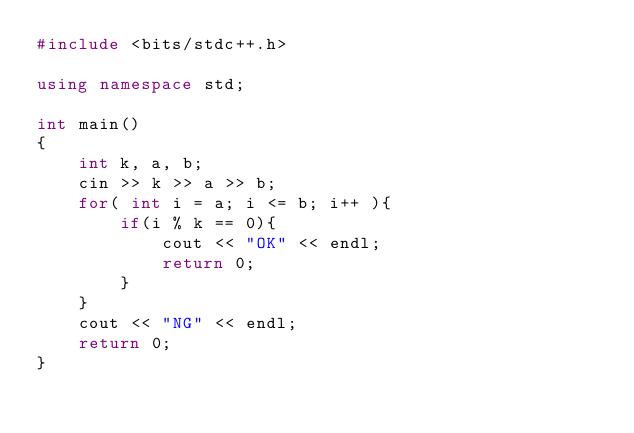<code> <loc_0><loc_0><loc_500><loc_500><_C++_>#include <bits/stdc++.h>

using namespace std;

int main()
{
    int k, a, b;
    cin >> k >> a >> b;
    for( int i = a; i <= b; i++ ){
        if(i % k == 0){
            cout << "OK" << endl;
            return 0;
        }
    }
    cout << "NG" << endl;
    return 0;
}</code> 